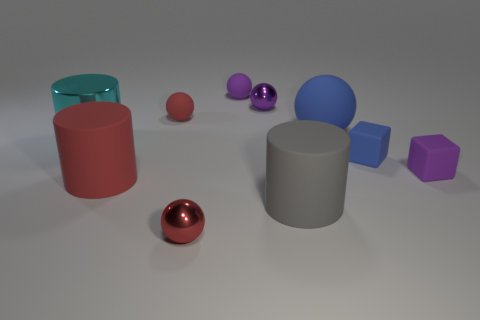Is there a big metal object?
Provide a short and direct response. Yes. What is the tiny purple sphere to the right of the tiny purple matte ball made of?
Provide a short and direct response. Metal. What number of tiny objects are either gray rubber cylinders or cyan things?
Your answer should be compact. 0. What color is the metal cylinder?
Provide a short and direct response. Cyan. Are there any red things that are left of the small sphere in front of the gray thing?
Make the answer very short. Yes. Are there fewer large cyan metal cylinders in front of the big metal thing than tiny blue cubes?
Your answer should be very brief. Yes. Is the big cylinder that is right of the red metallic sphere made of the same material as the cyan object?
Keep it short and to the point. No. There is a big sphere that is made of the same material as the small blue block; what is its color?
Offer a very short reply. Blue. Is the number of small purple rubber blocks that are left of the red matte sphere less than the number of tiny objects that are left of the large gray matte cylinder?
Ensure brevity in your answer.  Yes. There is a ball in front of the cyan object; is it the same color as the small rubber cube that is to the left of the purple rubber block?
Ensure brevity in your answer.  No. 